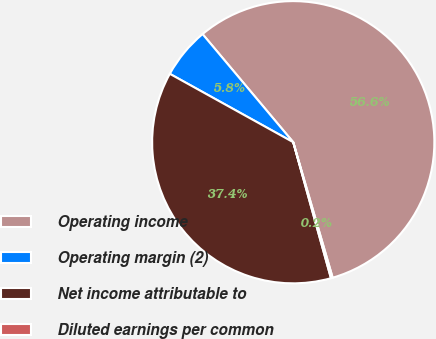<chart> <loc_0><loc_0><loc_500><loc_500><pie_chart><fcel>Operating income<fcel>Operating margin (2)<fcel>Net income attributable to<fcel>Diluted earnings per common<nl><fcel>56.6%<fcel>5.84%<fcel>37.36%<fcel>0.2%<nl></chart> 